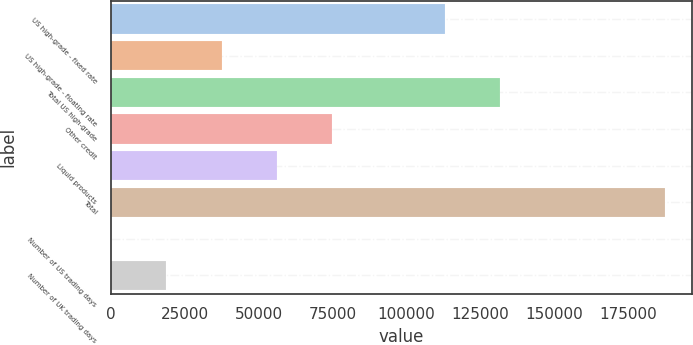Convert chart. <chart><loc_0><loc_0><loc_500><loc_500><bar_chart><fcel>US high-grade - fixed rate<fcel>US high-grade - floating rate<fcel>Total US high-grade<fcel>Other credit<fcel>Liquid products<fcel>Total<fcel>Number of US trading days<fcel>Number of UK trading days<nl><fcel>113128<fcel>37532.2<fcel>131864<fcel>75003.4<fcel>56267.8<fcel>187417<fcel>61<fcel>18796.6<nl></chart> 